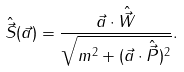Convert formula to latex. <formula><loc_0><loc_0><loc_500><loc_500>\hat { \vec { S } } ( \vec { a } ) = \frac { \vec { a } \cdot \hat { \vec { W } } } { \sqrt { m ^ { 2 } + ( \vec { a } \cdot \hat { \vec { P } } ) ^ { 2 } } } .</formula> 